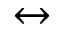Convert formula to latex. <formula><loc_0><loc_0><loc_500><loc_500>\leftrightarrow</formula> 